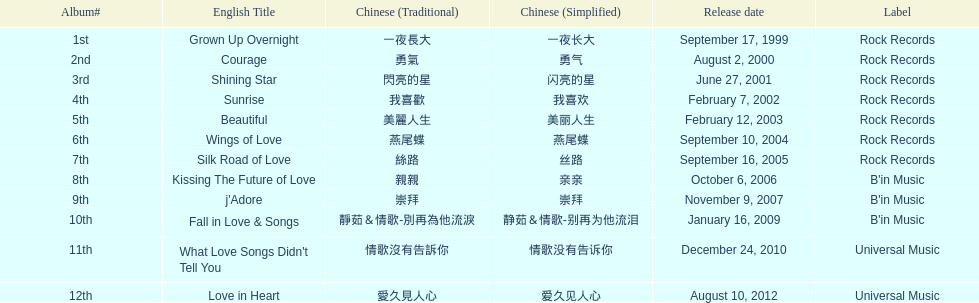Between beautiful and j'adore, which album came out more recently? J'adore. 